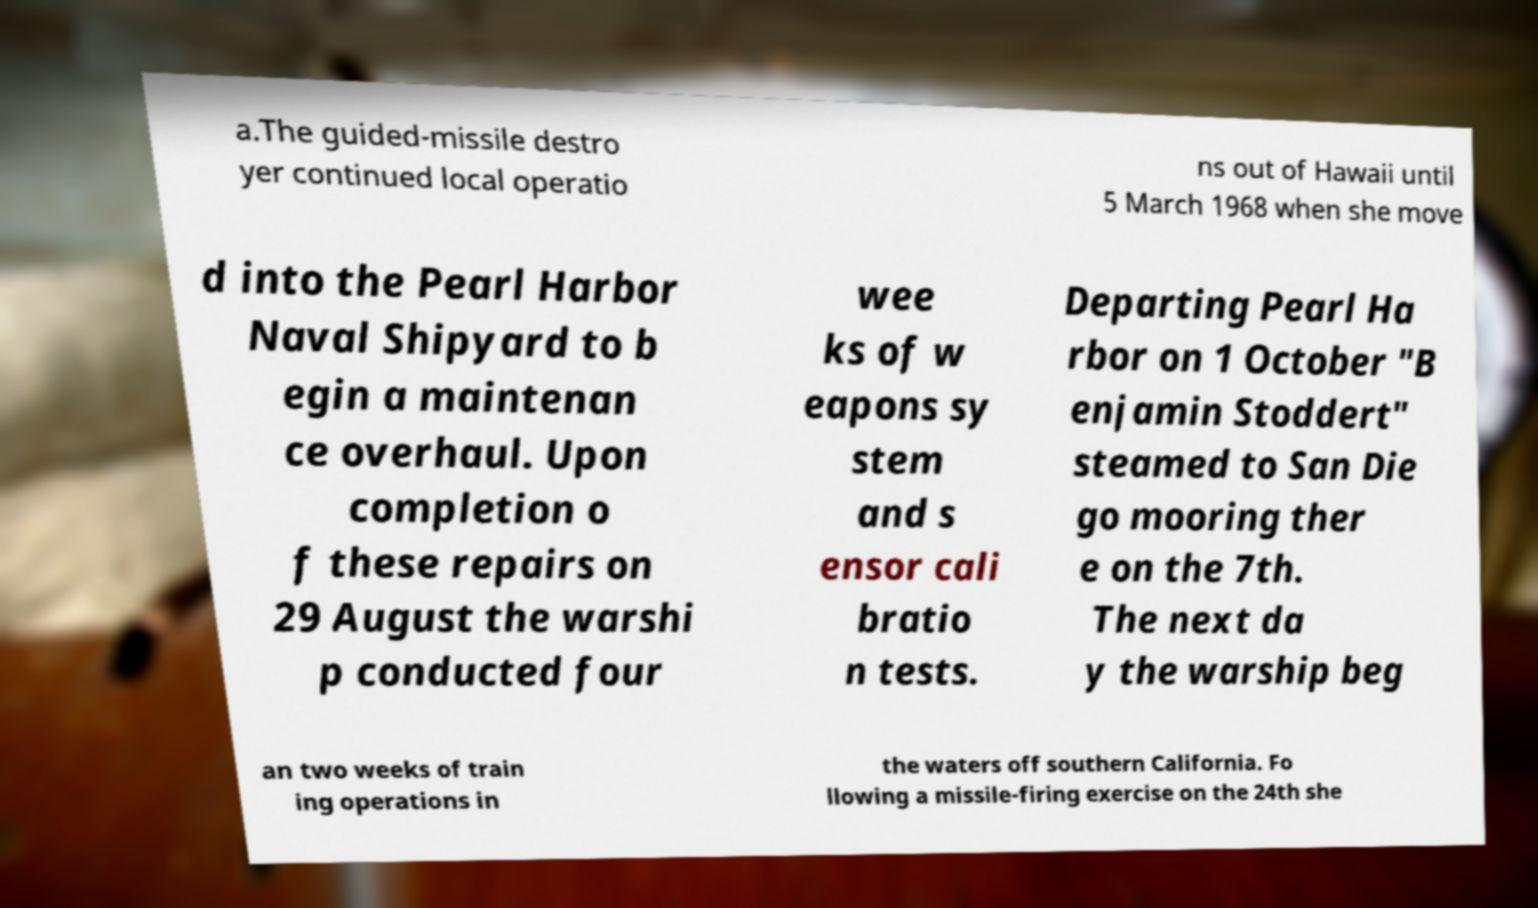Please read and relay the text visible in this image. What does it say? a.The guided-missile destro yer continued local operatio ns out of Hawaii until 5 March 1968 when she move d into the Pearl Harbor Naval Shipyard to b egin a maintenan ce overhaul. Upon completion o f these repairs on 29 August the warshi p conducted four wee ks of w eapons sy stem and s ensor cali bratio n tests. Departing Pearl Ha rbor on 1 October "B enjamin Stoddert" steamed to San Die go mooring ther e on the 7th. The next da y the warship beg an two weeks of train ing operations in the waters off southern California. Fo llowing a missile-firing exercise on the 24th she 